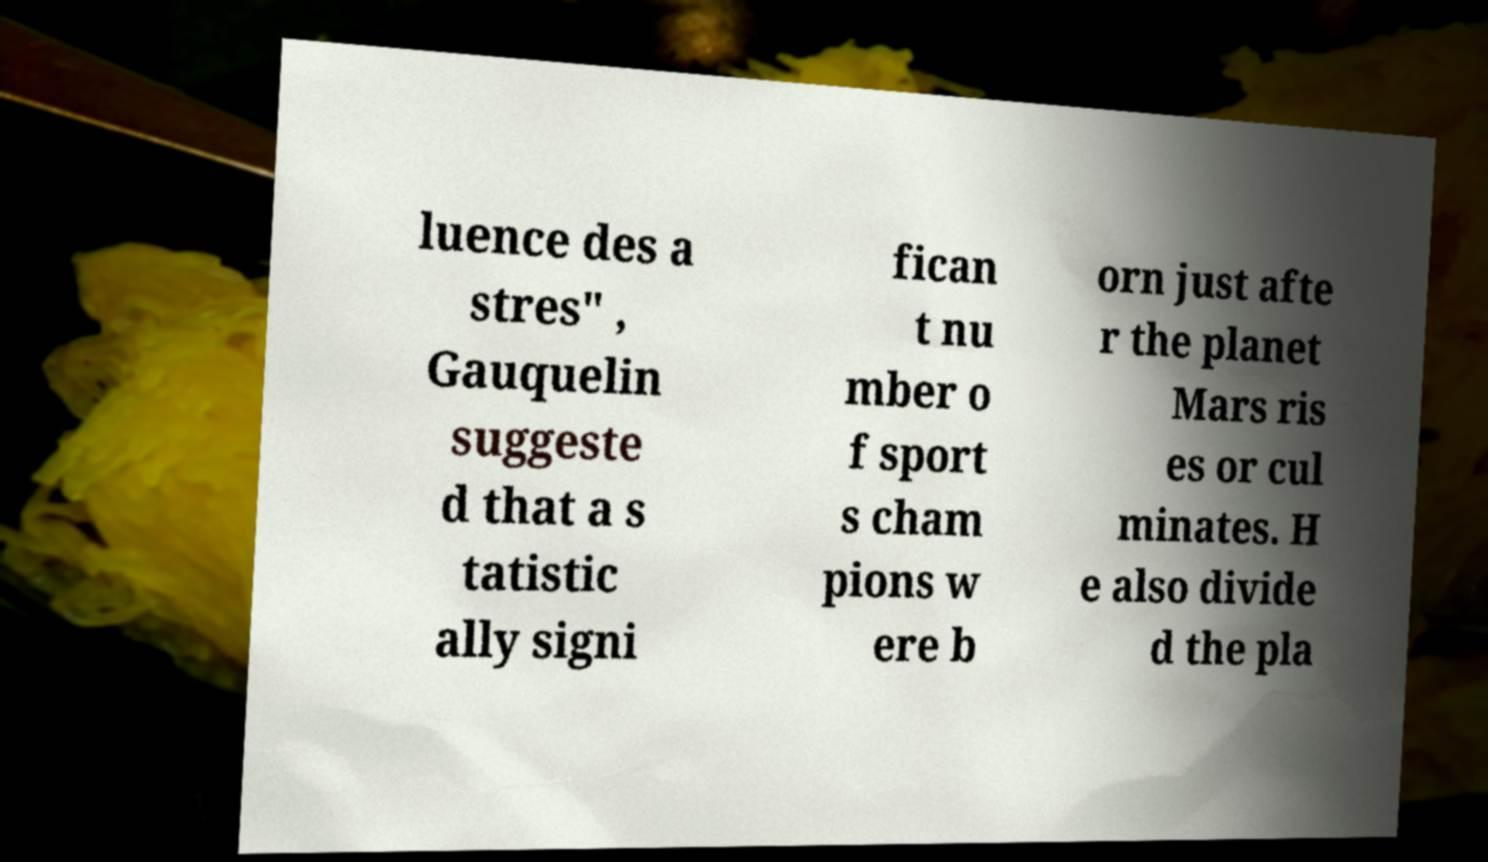For documentation purposes, I need the text within this image transcribed. Could you provide that? luence des a stres" , Gauquelin suggeste d that a s tatistic ally signi fican t nu mber o f sport s cham pions w ere b orn just afte r the planet Mars ris es or cul minates. H e also divide d the pla 